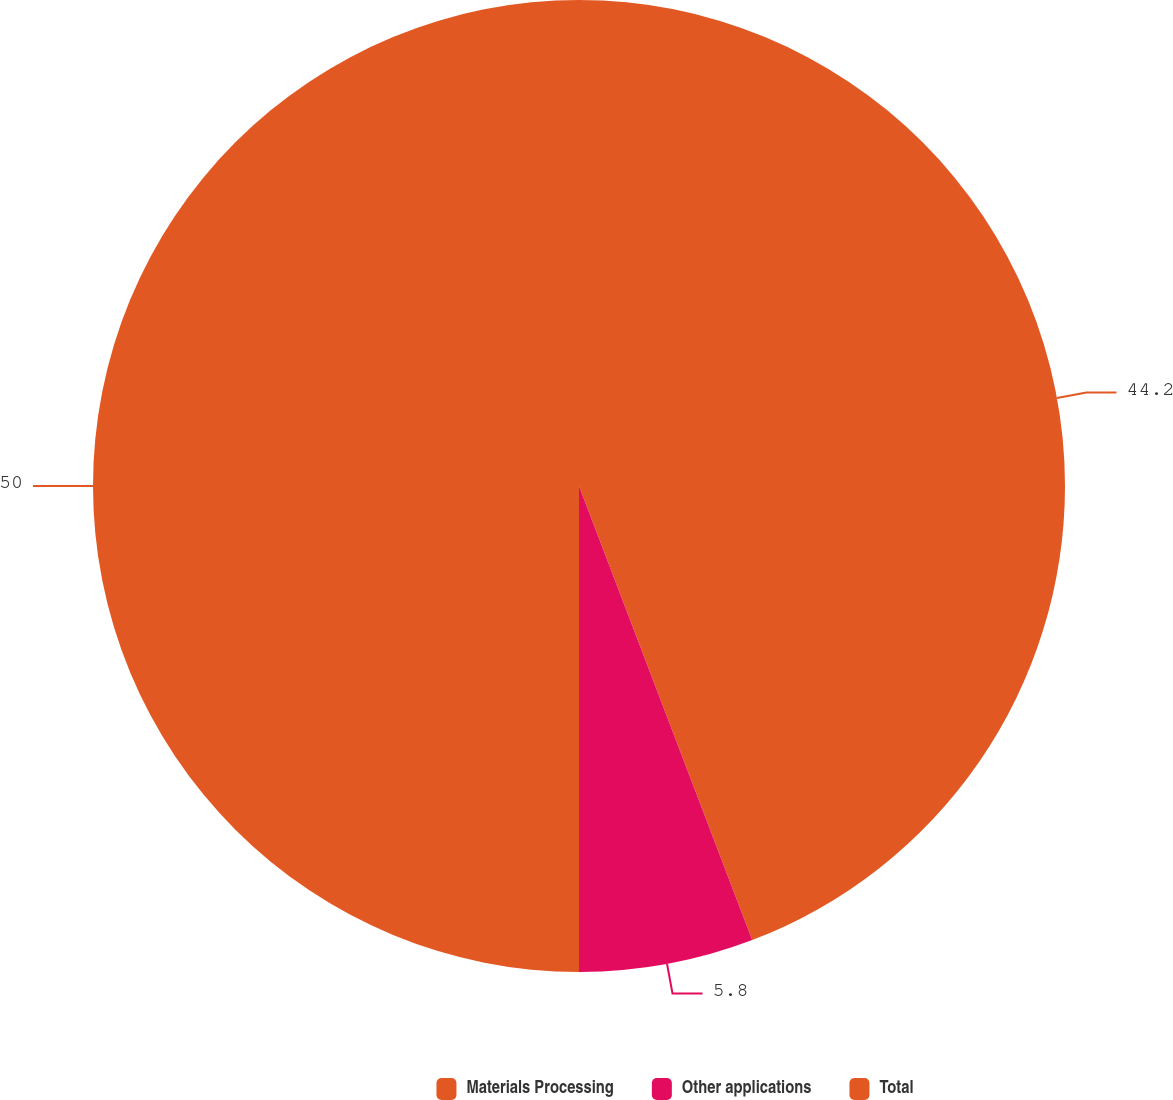<chart> <loc_0><loc_0><loc_500><loc_500><pie_chart><fcel>Materials Processing<fcel>Other applications<fcel>Total<nl><fcel>44.2%<fcel>5.8%<fcel>50.0%<nl></chart> 